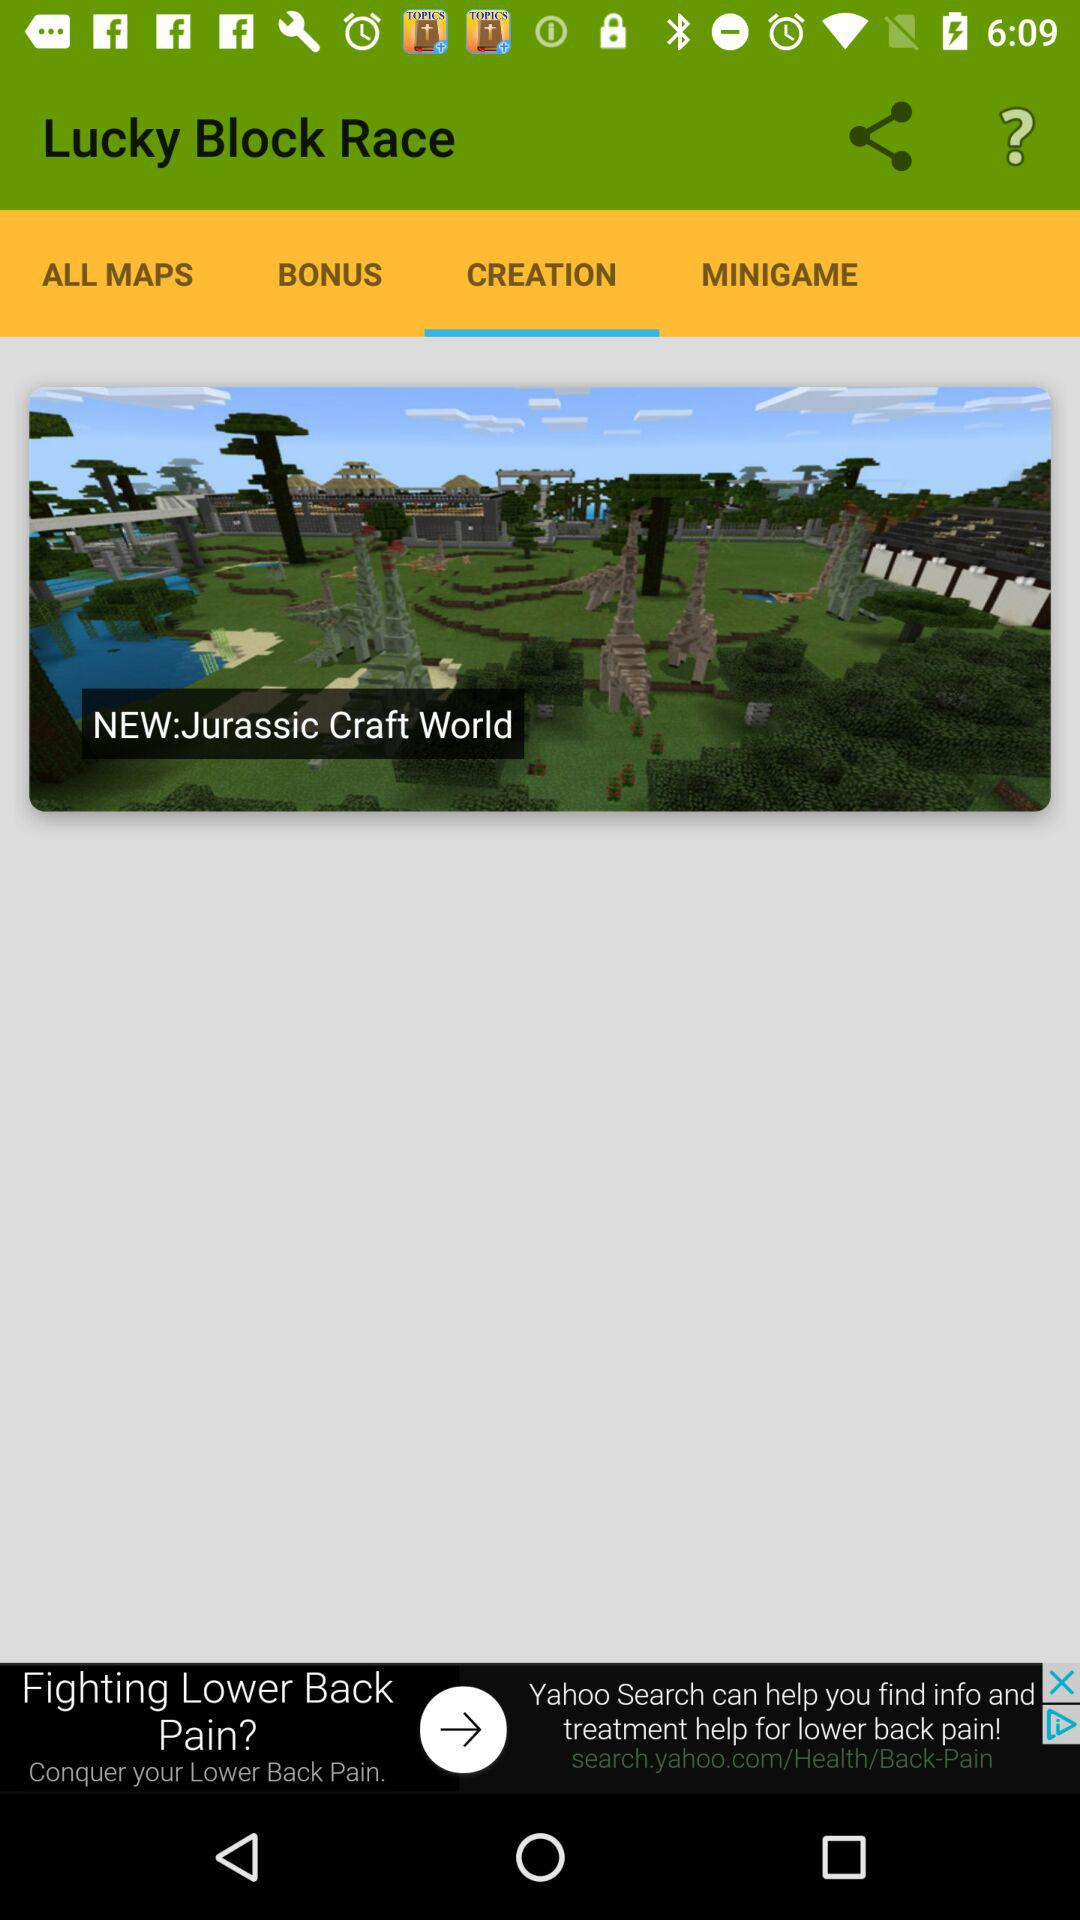Which tab is selected? The selected tab is "CREATION". 